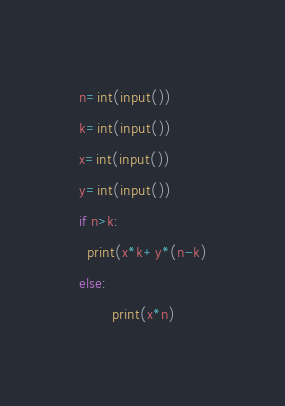<code> <loc_0><loc_0><loc_500><loc_500><_Python_>n=int(input())
k=int(input())
x=int(input())
y=int(input())
if n>k:
  print(x*k+y*(n-k)
else:
        print(x*n)</code> 